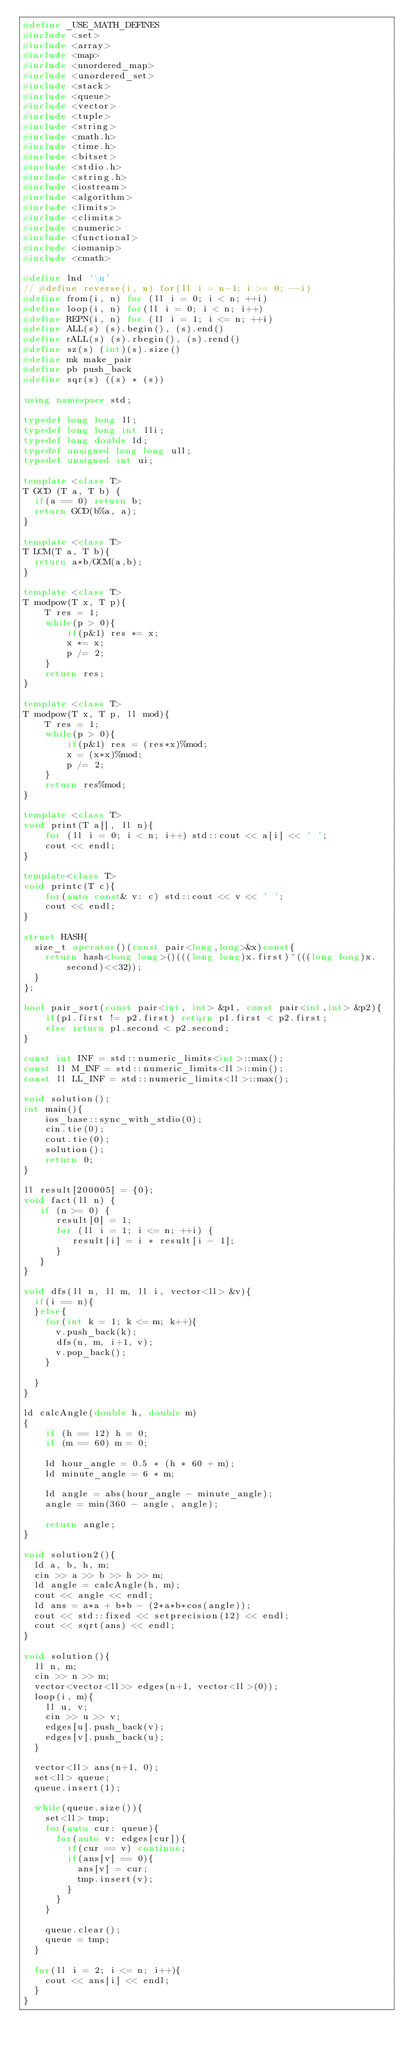<code> <loc_0><loc_0><loc_500><loc_500><_C++_>#define _USE_MATH_DEFINES
#include <set>
#include <array>
#include <map>
#include <unordered_map>
#include <unordered_set>
#include <stack>
#include <queue>
#include <vector>
#include <tuple>
#include <string>
#include <math.h>
#include <time.h>
#include <bitset>
#include <stdio.h>
#include <string.h>
#include <iostream>
#include <algorithm>
#include <limits>
#include <climits>
#include <numeric>
#include <functional>
#include <iomanip>
#include <cmath>

#define lnd '\n'
// #define reverse(i, n) for(ll i = n-1; i >= 0; --i)
#define from(i, n) for (ll i = 0; i < n; ++i)
#define loop(i, n) for(ll i = 0; i < n; i++)
#define REPN(i, n) for (ll i = 1; i <= n; ++i)
#define ALL(s) (s).begin(), (s).end()
#define rALL(s) (s).rbegin(), (s).rend()
#define sz(s) (int)(s).size()
#define mk make_pair
#define pb push_back
#define sqr(s) ((s) * (s))

using namespace std;

typedef long long ll;
typedef long long int lli;
typedef long double ld;
typedef unsigned long long ull;
typedef unsigned int ui;

template <class T>
T GCD (T a, T b) {
  if(a == 0) return b;
  return GCD(b%a, a);
}

template <class T>
T LCM(T a, T b){
  return a*b/GCM(a,b);
}

template <class T>
T modpow(T x, T p){
    T res = 1;
    while(p > 0){
        if(p&1) res *= x;
        x *= x;
        p /= 2;
    }
    return res;
}

template <class T>
T modpow(T x, T p, ll mod){
    T res = 1;
    while(p > 0){
        if(p&1) res = (res*x)%mod;
        x = (x*x)%mod;
        p /= 2;
    }
    return res%mod;
}

template <class T>
void print(T a[], ll n){
    for (ll i = 0; i < n; i++) std::cout << a[i] << ' ';
    cout << endl;
}

template<class T>
void printc(T c){
    for(auto const& v: c) std::cout << v << ' ';
    cout << endl;
}

struct HASH{
  size_t operator()(const pair<long,long>&x)const{
    return hash<long long>()(((long long)x.first)^(((long long)x.second)<<32));
  }
};

bool pair_sort(const pair<int, int> &p1, const pair<int,int> &p2){
    if(p1.first != p2.first) return p1.first < p2.first;
    else return p1.second < p2.second;
}

const int INF = std::numeric_limits<int>::max();
const ll M_INF = std::numeric_limits<ll>::min();
const ll LL_INF = std::numeric_limits<ll>::max();

void solution();
int main(){
    ios_base::sync_with_stdio(0);
    cin.tie(0);
    cout.tie(0);
    solution();
    return 0;
}

ll result[200005] = {0};
void fact(ll n) {
   if (n >= 0) {
      result[0] = 1;
      for (ll i = 1; i <= n; ++i) {
         result[i] = i * result[i - 1];
      }
   }
}

void dfs(ll n, ll m, ll i, vector<ll> &v){
  if(i == n){
  }else{
    for(int k = 1; k <= m; k++){
      v.push_back(k);
      dfs(n, m, i+1, v);
      v.pop_back();
    }
  
  }
}

ld calcAngle(double h, double m)  
{  
    if (h == 12) h = 0;  
    if (m == 60) m = 0;  
   
    ld hour_angle = 0.5 * (h * 60 + m);  
    ld minute_angle = 6 * m;  
  
    ld angle = abs(hour_angle - minute_angle);    
    angle = min(360 - angle, angle);  
  
    return angle;  
}

void solution2(){
  ld a, b, h, m;
  cin >> a >> b >> h >> m;
  ld angle = calcAngle(h, m);
  cout << angle << endl;
  ld ans = a*a + b*b - (2*a*b*cos(angle));
  cout << std::fixed << setprecision(12) << endl;
  cout << sqrt(ans) << endl;
}    

void solution(){
  ll n, m;
  cin >> n >> m;
  vector<vector<ll>> edges(n+1, vector<ll>(0));
  loop(i, m){
    ll u, v;
    cin >> u >> v;
    edges[u].push_back(v);
    edges[v].push_back(u);
  }

  vector<ll> ans(n+1, 0);
  set<ll> queue;
  queue.insert(1);

  while(queue.size()){
    set<ll> tmp;
    for(auto cur: queue){
      for(auto v: edges[cur]){
        if(cur == v) continue;
        if(ans[v] == 0){
          ans[v] = cur;
          tmp.insert(v);
        }
      }
    }

    queue.clear();
    queue = tmp;
  }

  for(ll i = 2; i <= n; i++){
    cout << ans[i] << endl;
  }
}

</code> 